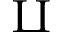<formula> <loc_0><loc_0><loc_500><loc_500>\amalg</formula> 